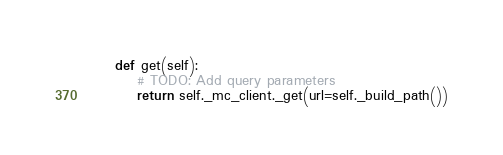<code> <loc_0><loc_0><loc_500><loc_500><_Python_>
    def get(self):
    	# TODO: Add query parameters
        return self._mc_client._get(url=self._build_path())
</code> 